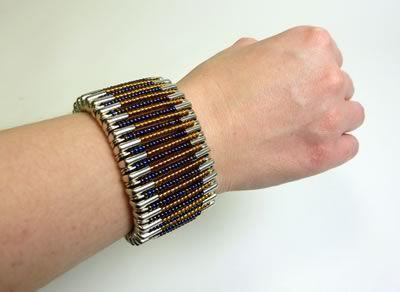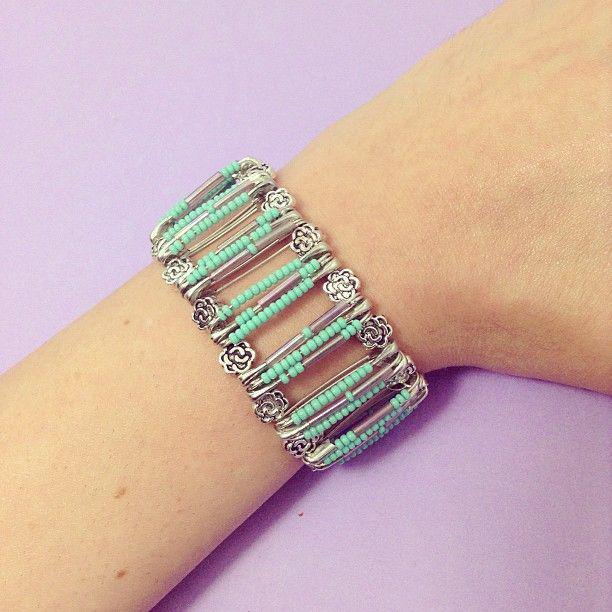The first image is the image on the left, the second image is the image on the right. For the images shown, is this caption "there is a human wearing a bracelet in each image." true? Answer yes or no. Yes. The first image is the image on the left, the second image is the image on the right. Considering the images on both sides, is "An image shows an unworn bracelet made of silver safety pins strung with different bead colors." valid? Answer yes or no. No. 